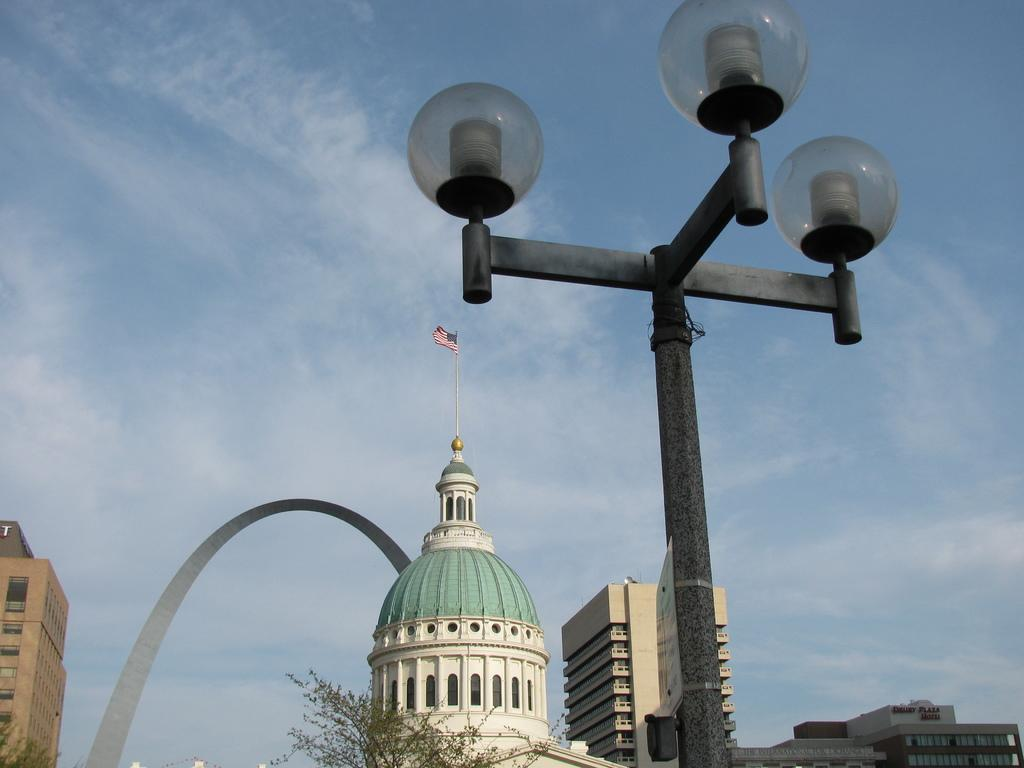What type of structures can be seen in the image? There are buildings in the image. Is there any specific feature on top of one of the buildings? Yes, there is a flag on top of a building. What else can be seen in the image besides buildings? There is a pole with lights and trees in the image. What can be seen in the background of the image? The sky is visible in the background of the image. What type of writing can be seen on the buildings in the image? There is no writing visible on the buildings in the image. What sound can be heard coming from the lights on the pole in the image? There is no sound associated with the lights on the pole in the image. 